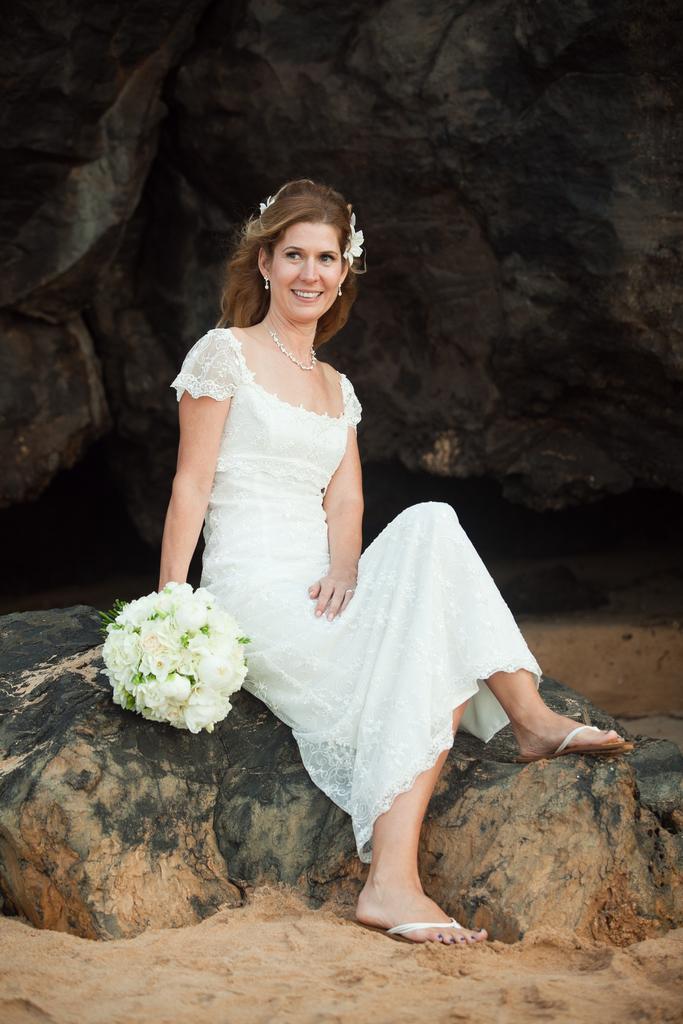Can you describe this image briefly? In this picture we can see a woman in the white dress is holding a bouquet and sitting. Behind the woman there is a rock. 